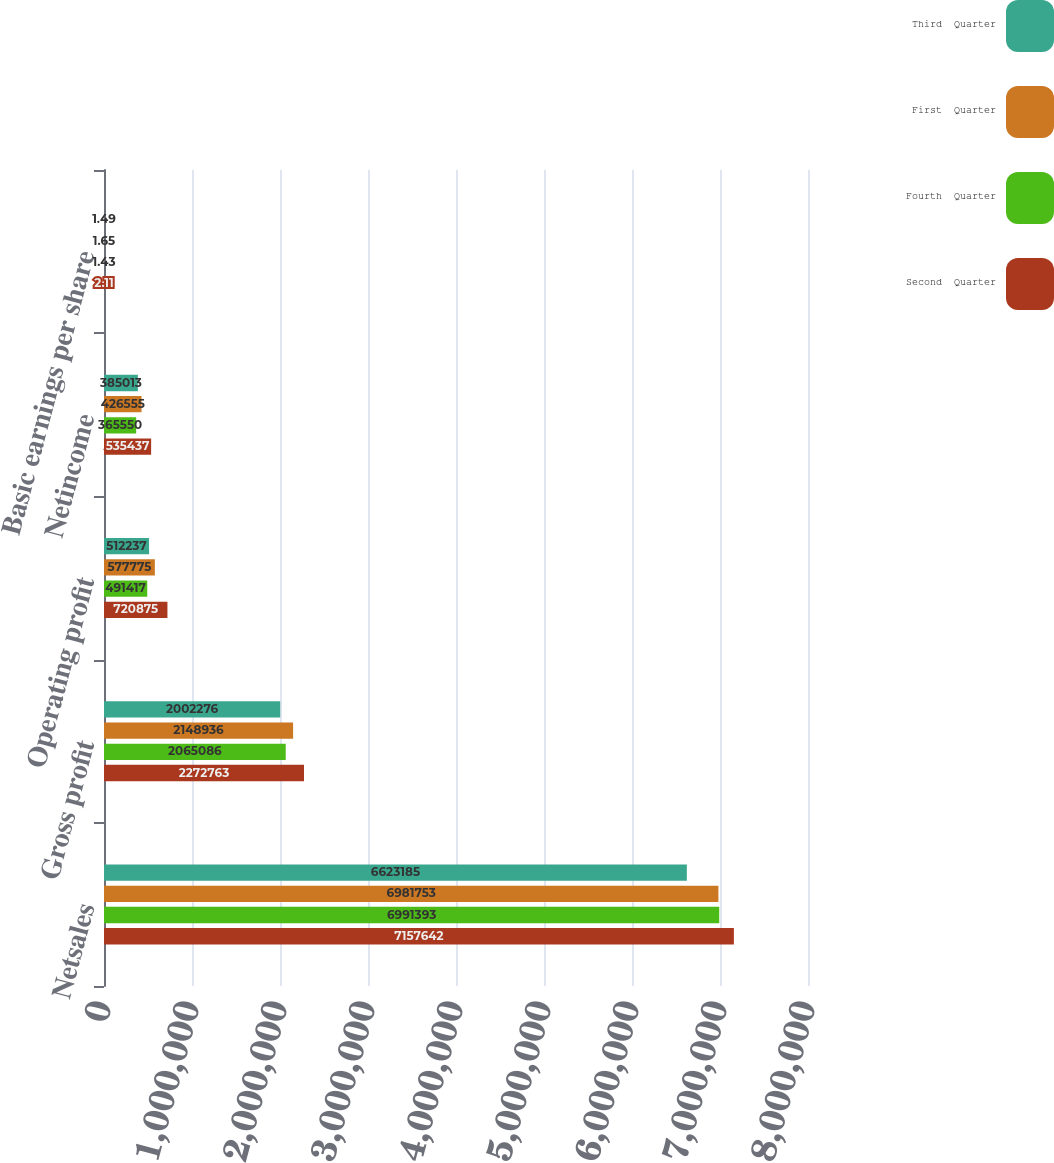Convert chart. <chart><loc_0><loc_0><loc_500><loc_500><stacked_bar_chart><ecel><fcel>Netsales<fcel>Gross profit<fcel>Operating profit<fcel>Netincome<fcel>Basic earnings per share<nl><fcel>Third  Quarter<fcel>6.62318e+06<fcel>2.00228e+06<fcel>512237<fcel>385013<fcel>1.49<nl><fcel>First  Quarter<fcel>6.98175e+06<fcel>2.14894e+06<fcel>577775<fcel>426555<fcel>1.65<nl><fcel>Fourth  Quarter<fcel>6.99139e+06<fcel>2.06509e+06<fcel>491417<fcel>365550<fcel>1.43<nl><fcel>Second  Quarter<fcel>7.15764e+06<fcel>2.27276e+06<fcel>720875<fcel>535437<fcel>2.11<nl></chart> 